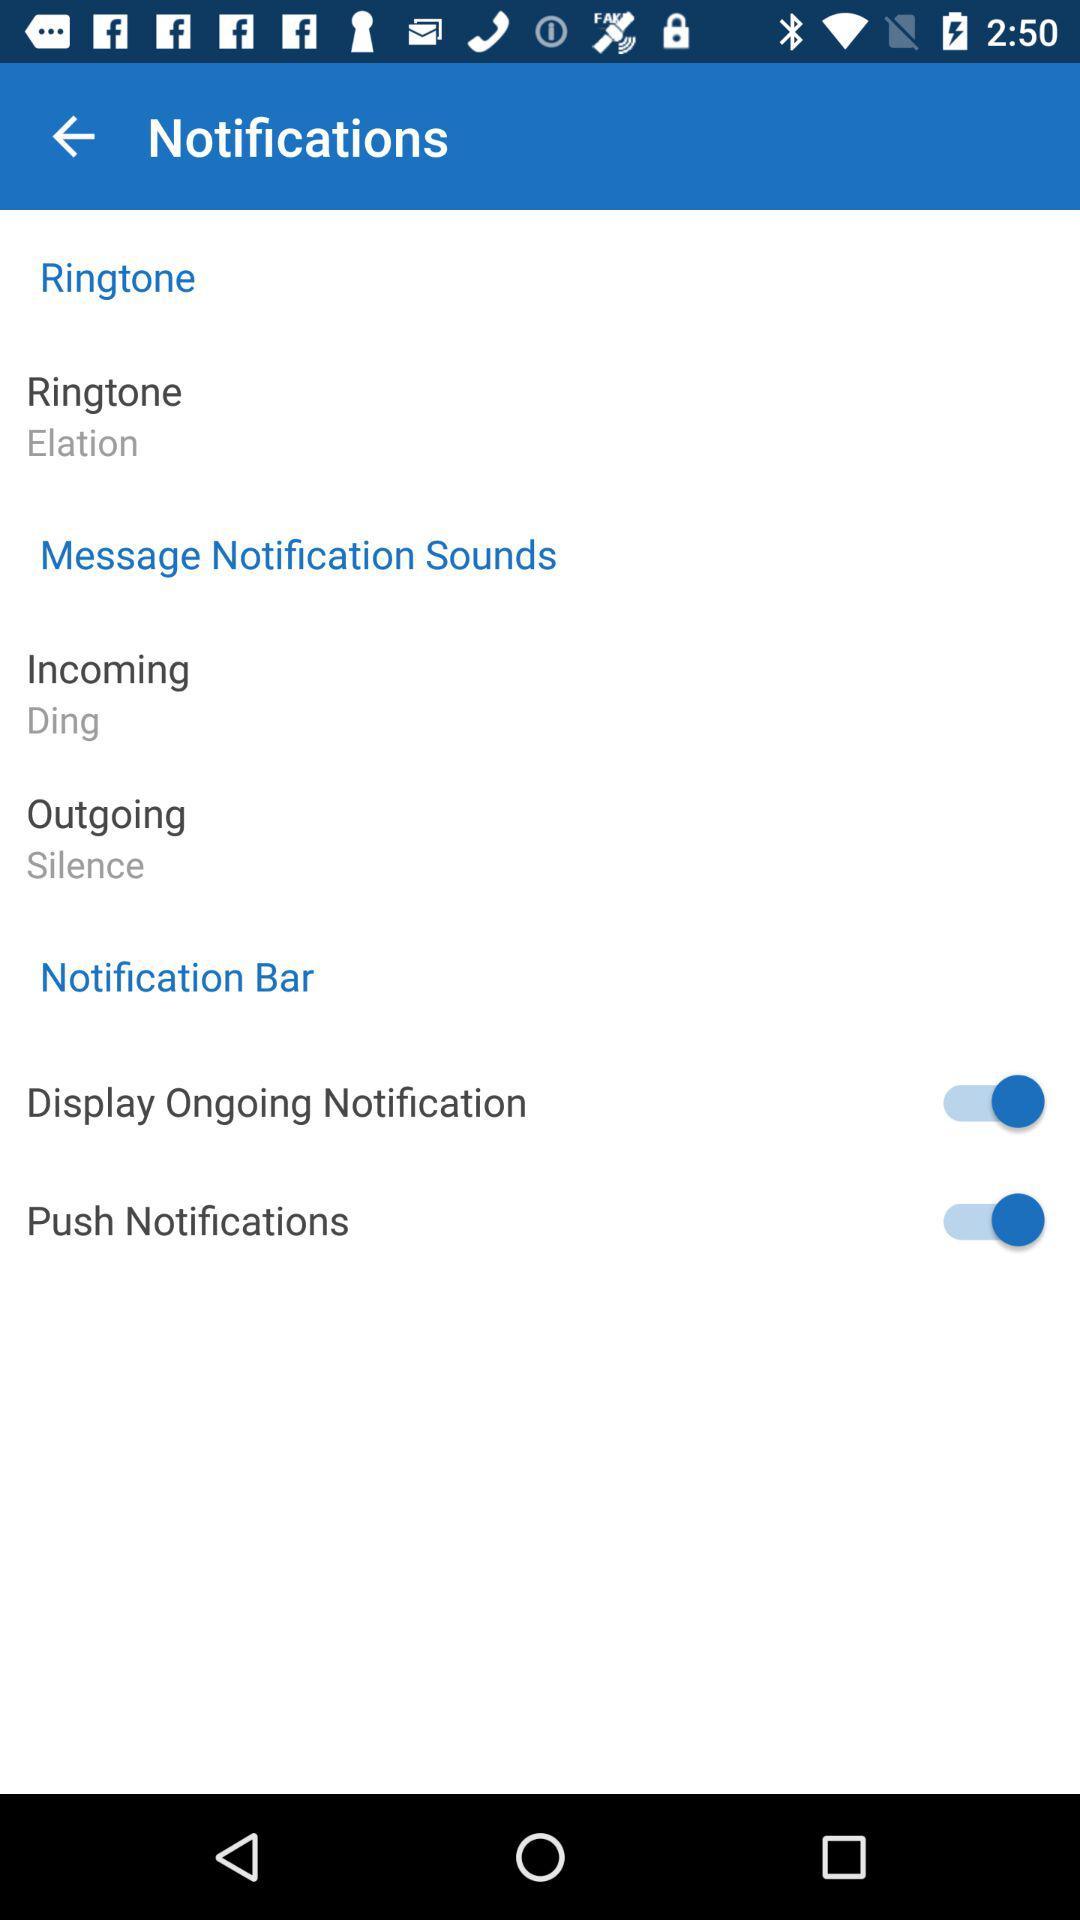What is the status of "Push Notifications"? The status of "Push Notifications" is "on". 